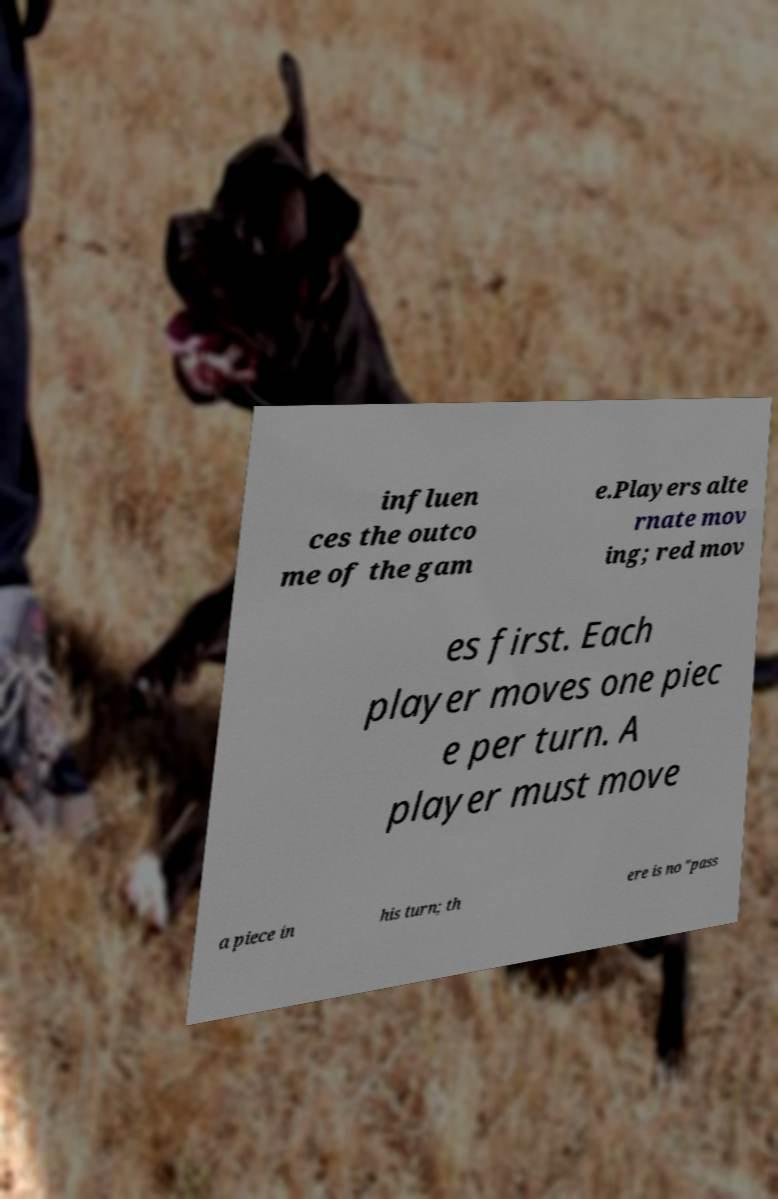For documentation purposes, I need the text within this image transcribed. Could you provide that? influen ces the outco me of the gam e.Players alte rnate mov ing; red mov es first. Each player moves one piec e per turn. A player must move a piece in his turn; th ere is no "pass 